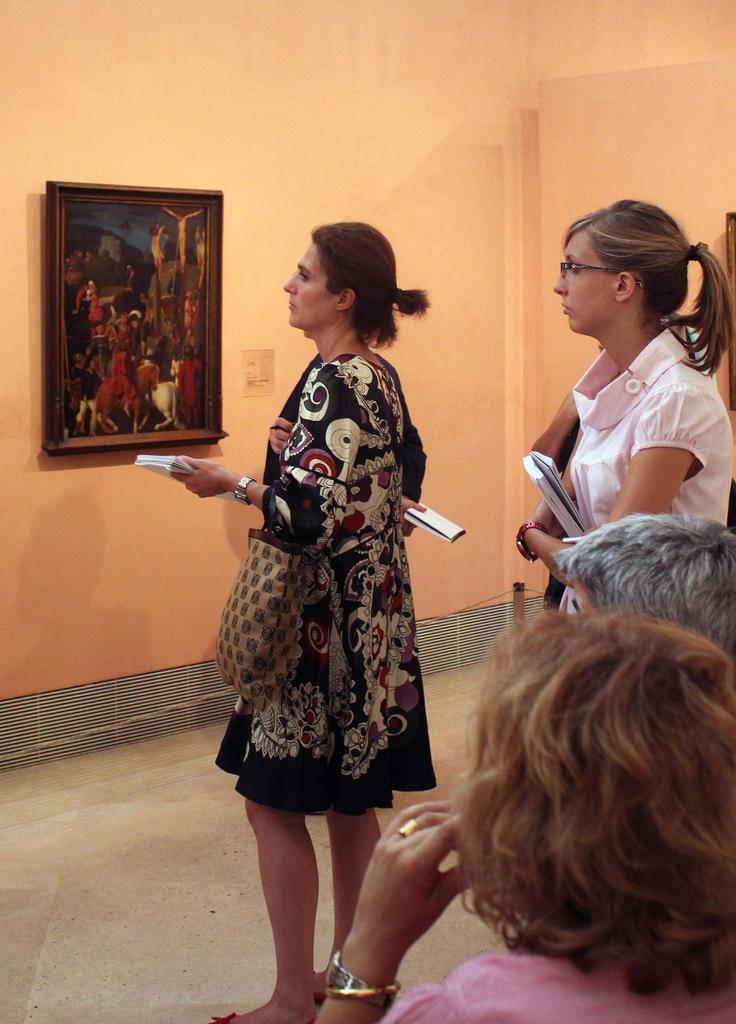How many people are in the image? There are people in the image. What are the people holding in the image? Two people are holding bags and books in the image. What is the frame attached to in the image? The frame is attached to a cream-colored wall in the image. What type of milk is being poured into the frame in the image? There is no milk being poured into the frame in the image. What kind of apparel are the people wearing in the image? The provided facts do not mention the apparel worn by the people in the image. 